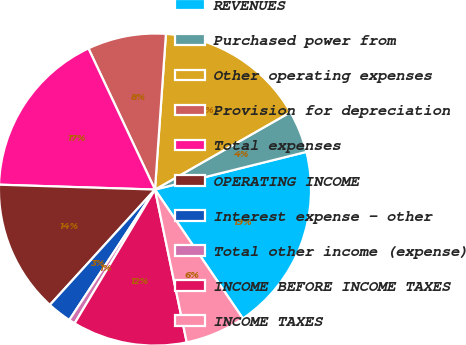Convert chart to OTSL. <chart><loc_0><loc_0><loc_500><loc_500><pie_chart><fcel>REVENUES<fcel>Purchased power from<fcel>Other operating expenses<fcel>Provision for depreciation<fcel>Total expenses<fcel>OPERATING INCOME<fcel>Interest expense - other<fcel>Total other income (expense)<fcel>INCOME BEFORE INCOME TAXES<fcel>INCOME TAXES<nl><fcel>19.36%<fcel>4.38%<fcel>15.62%<fcel>8.13%<fcel>17.49%<fcel>13.74%<fcel>2.51%<fcel>0.64%<fcel>11.87%<fcel>6.26%<nl></chart> 